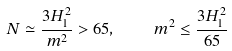Convert formula to latex. <formula><loc_0><loc_0><loc_500><loc_500>N \simeq \frac { 3 H _ { 1 } ^ { 2 } } { m ^ { 2 } } > 6 5 , \quad m ^ { 2 } \leq \frac { 3 H _ { 1 } ^ { 2 } } { 6 5 }</formula> 